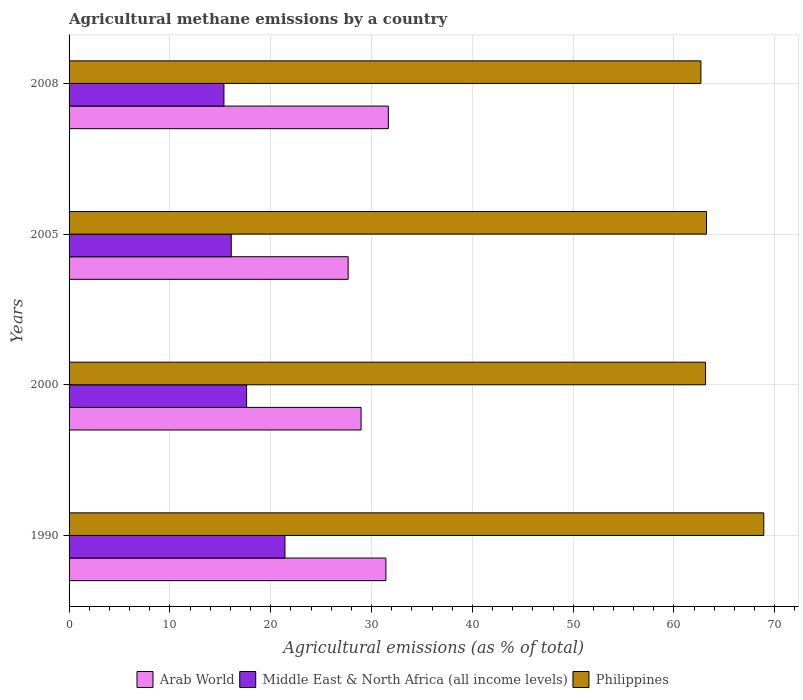Are the number of bars per tick equal to the number of legend labels?
Keep it short and to the point. Yes. Are the number of bars on each tick of the Y-axis equal?
Give a very brief answer. Yes. How many bars are there on the 3rd tick from the bottom?
Provide a succinct answer. 3. What is the amount of agricultural methane emitted in Philippines in 1990?
Keep it short and to the point. 68.9. Across all years, what is the maximum amount of agricultural methane emitted in Middle East & North Africa (all income levels)?
Provide a succinct answer. 21.41. Across all years, what is the minimum amount of agricultural methane emitted in Arab World?
Offer a terse response. 27.68. What is the total amount of agricultural methane emitted in Middle East & North Africa (all income levels) in the graph?
Offer a terse response. 70.47. What is the difference between the amount of agricultural methane emitted in Middle East & North Africa (all income levels) in 2000 and that in 2008?
Your response must be concise. 2.25. What is the difference between the amount of agricultural methane emitted in Arab World in 2005 and the amount of agricultural methane emitted in Middle East & North Africa (all income levels) in 2008?
Make the answer very short. 12.32. What is the average amount of agricultural methane emitted in Middle East & North Africa (all income levels) per year?
Make the answer very short. 17.62. In the year 1990, what is the difference between the amount of agricultural methane emitted in Middle East & North Africa (all income levels) and amount of agricultural methane emitted in Philippines?
Offer a terse response. -47.49. In how many years, is the amount of agricultural methane emitted in Arab World greater than 52 %?
Offer a very short reply. 0. What is the ratio of the amount of agricultural methane emitted in Philippines in 2000 to that in 2005?
Give a very brief answer. 1. Is the amount of agricultural methane emitted in Philippines in 1990 less than that in 2000?
Offer a very short reply. No. Is the difference between the amount of agricultural methane emitted in Middle East & North Africa (all income levels) in 1990 and 2000 greater than the difference between the amount of agricultural methane emitted in Philippines in 1990 and 2000?
Provide a succinct answer. No. What is the difference between the highest and the second highest amount of agricultural methane emitted in Arab World?
Ensure brevity in your answer.  0.24. What is the difference between the highest and the lowest amount of agricultural methane emitted in Middle East & North Africa (all income levels)?
Keep it short and to the point. 6.05. In how many years, is the amount of agricultural methane emitted in Arab World greater than the average amount of agricultural methane emitted in Arab World taken over all years?
Your answer should be compact. 2. What does the 1st bar from the top in 2000 represents?
Your answer should be very brief. Philippines. What does the 2nd bar from the bottom in 2005 represents?
Give a very brief answer. Middle East & North Africa (all income levels). Is it the case that in every year, the sum of the amount of agricultural methane emitted in Philippines and amount of agricultural methane emitted in Arab World is greater than the amount of agricultural methane emitted in Middle East & North Africa (all income levels)?
Provide a short and direct response. Yes. Are all the bars in the graph horizontal?
Your answer should be compact. Yes. What is the difference between two consecutive major ticks on the X-axis?
Offer a terse response. 10. Are the values on the major ticks of X-axis written in scientific E-notation?
Keep it short and to the point. No. Does the graph contain grids?
Provide a short and direct response. Yes. What is the title of the graph?
Your response must be concise. Agricultural methane emissions by a country. Does "Guyana" appear as one of the legend labels in the graph?
Offer a terse response. No. What is the label or title of the X-axis?
Provide a succinct answer. Agricultural emissions (as % of total). What is the Agricultural emissions (as % of total) in Arab World in 1990?
Keep it short and to the point. 31.42. What is the Agricultural emissions (as % of total) of Middle East & North Africa (all income levels) in 1990?
Offer a very short reply. 21.41. What is the Agricultural emissions (as % of total) in Philippines in 1990?
Your answer should be very brief. 68.9. What is the Agricultural emissions (as % of total) in Arab World in 2000?
Your response must be concise. 28.96. What is the Agricultural emissions (as % of total) in Middle East & North Africa (all income levels) in 2000?
Offer a very short reply. 17.61. What is the Agricultural emissions (as % of total) of Philippines in 2000?
Your response must be concise. 63.13. What is the Agricultural emissions (as % of total) of Arab World in 2005?
Your answer should be compact. 27.68. What is the Agricultural emissions (as % of total) of Middle East & North Africa (all income levels) in 2005?
Offer a terse response. 16.09. What is the Agricultural emissions (as % of total) in Philippines in 2005?
Ensure brevity in your answer.  63.22. What is the Agricultural emissions (as % of total) of Arab World in 2008?
Your answer should be very brief. 31.67. What is the Agricultural emissions (as % of total) in Middle East & North Africa (all income levels) in 2008?
Keep it short and to the point. 15.36. What is the Agricultural emissions (as % of total) of Philippines in 2008?
Your answer should be very brief. 62.67. Across all years, what is the maximum Agricultural emissions (as % of total) of Arab World?
Keep it short and to the point. 31.67. Across all years, what is the maximum Agricultural emissions (as % of total) of Middle East & North Africa (all income levels)?
Your response must be concise. 21.41. Across all years, what is the maximum Agricultural emissions (as % of total) in Philippines?
Offer a very short reply. 68.9. Across all years, what is the minimum Agricultural emissions (as % of total) in Arab World?
Keep it short and to the point. 27.68. Across all years, what is the minimum Agricultural emissions (as % of total) of Middle East & North Africa (all income levels)?
Offer a terse response. 15.36. Across all years, what is the minimum Agricultural emissions (as % of total) of Philippines?
Give a very brief answer. 62.67. What is the total Agricultural emissions (as % of total) of Arab World in the graph?
Provide a succinct answer. 119.73. What is the total Agricultural emissions (as % of total) of Middle East & North Africa (all income levels) in the graph?
Your response must be concise. 70.47. What is the total Agricultural emissions (as % of total) in Philippines in the graph?
Provide a succinct answer. 257.93. What is the difference between the Agricultural emissions (as % of total) of Arab World in 1990 and that in 2000?
Give a very brief answer. 2.46. What is the difference between the Agricultural emissions (as % of total) of Middle East & North Africa (all income levels) in 1990 and that in 2000?
Offer a terse response. 3.81. What is the difference between the Agricultural emissions (as % of total) of Philippines in 1990 and that in 2000?
Provide a succinct answer. 5.77. What is the difference between the Agricultural emissions (as % of total) of Arab World in 1990 and that in 2005?
Your response must be concise. 3.74. What is the difference between the Agricultural emissions (as % of total) in Middle East & North Africa (all income levels) in 1990 and that in 2005?
Offer a very short reply. 5.33. What is the difference between the Agricultural emissions (as % of total) of Philippines in 1990 and that in 2005?
Provide a succinct answer. 5.68. What is the difference between the Agricultural emissions (as % of total) of Arab World in 1990 and that in 2008?
Your answer should be very brief. -0.24. What is the difference between the Agricultural emissions (as % of total) in Middle East & North Africa (all income levels) in 1990 and that in 2008?
Offer a terse response. 6.05. What is the difference between the Agricultural emissions (as % of total) of Philippines in 1990 and that in 2008?
Your answer should be very brief. 6.23. What is the difference between the Agricultural emissions (as % of total) of Arab World in 2000 and that in 2005?
Your answer should be compact. 1.28. What is the difference between the Agricultural emissions (as % of total) in Middle East & North Africa (all income levels) in 2000 and that in 2005?
Your response must be concise. 1.52. What is the difference between the Agricultural emissions (as % of total) of Philippines in 2000 and that in 2005?
Offer a terse response. -0.09. What is the difference between the Agricultural emissions (as % of total) in Arab World in 2000 and that in 2008?
Provide a short and direct response. -2.7. What is the difference between the Agricultural emissions (as % of total) in Middle East & North Africa (all income levels) in 2000 and that in 2008?
Make the answer very short. 2.25. What is the difference between the Agricultural emissions (as % of total) in Philippines in 2000 and that in 2008?
Your answer should be compact. 0.46. What is the difference between the Agricultural emissions (as % of total) of Arab World in 2005 and that in 2008?
Your response must be concise. -3.99. What is the difference between the Agricultural emissions (as % of total) in Middle East & North Africa (all income levels) in 2005 and that in 2008?
Provide a short and direct response. 0.72. What is the difference between the Agricultural emissions (as % of total) in Philippines in 2005 and that in 2008?
Offer a terse response. 0.55. What is the difference between the Agricultural emissions (as % of total) in Arab World in 1990 and the Agricultural emissions (as % of total) in Middle East & North Africa (all income levels) in 2000?
Offer a very short reply. 13.81. What is the difference between the Agricultural emissions (as % of total) of Arab World in 1990 and the Agricultural emissions (as % of total) of Philippines in 2000?
Ensure brevity in your answer.  -31.71. What is the difference between the Agricultural emissions (as % of total) of Middle East & North Africa (all income levels) in 1990 and the Agricultural emissions (as % of total) of Philippines in 2000?
Give a very brief answer. -41.72. What is the difference between the Agricultural emissions (as % of total) of Arab World in 1990 and the Agricultural emissions (as % of total) of Middle East & North Africa (all income levels) in 2005?
Ensure brevity in your answer.  15.34. What is the difference between the Agricultural emissions (as % of total) in Arab World in 1990 and the Agricultural emissions (as % of total) in Philippines in 2005?
Offer a terse response. -31.8. What is the difference between the Agricultural emissions (as % of total) of Middle East & North Africa (all income levels) in 1990 and the Agricultural emissions (as % of total) of Philippines in 2005?
Provide a succinct answer. -41.81. What is the difference between the Agricultural emissions (as % of total) of Arab World in 1990 and the Agricultural emissions (as % of total) of Middle East & North Africa (all income levels) in 2008?
Offer a terse response. 16.06. What is the difference between the Agricultural emissions (as % of total) in Arab World in 1990 and the Agricultural emissions (as % of total) in Philippines in 2008?
Offer a very short reply. -31.25. What is the difference between the Agricultural emissions (as % of total) of Middle East & North Africa (all income levels) in 1990 and the Agricultural emissions (as % of total) of Philippines in 2008?
Provide a succinct answer. -41.26. What is the difference between the Agricultural emissions (as % of total) of Arab World in 2000 and the Agricultural emissions (as % of total) of Middle East & North Africa (all income levels) in 2005?
Make the answer very short. 12.88. What is the difference between the Agricultural emissions (as % of total) in Arab World in 2000 and the Agricultural emissions (as % of total) in Philippines in 2005?
Your response must be concise. -34.26. What is the difference between the Agricultural emissions (as % of total) of Middle East & North Africa (all income levels) in 2000 and the Agricultural emissions (as % of total) of Philippines in 2005?
Provide a succinct answer. -45.62. What is the difference between the Agricultural emissions (as % of total) in Arab World in 2000 and the Agricultural emissions (as % of total) in Middle East & North Africa (all income levels) in 2008?
Provide a short and direct response. 13.6. What is the difference between the Agricultural emissions (as % of total) in Arab World in 2000 and the Agricultural emissions (as % of total) in Philippines in 2008?
Provide a short and direct response. -33.71. What is the difference between the Agricultural emissions (as % of total) in Middle East & North Africa (all income levels) in 2000 and the Agricultural emissions (as % of total) in Philippines in 2008?
Your answer should be compact. -45.06. What is the difference between the Agricultural emissions (as % of total) in Arab World in 2005 and the Agricultural emissions (as % of total) in Middle East & North Africa (all income levels) in 2008?
Make the answer very short. 12.32. What is the difference between the Agricultural emissions (as % of total) in Arab World in 2005 and the Agricultural emissions (as % of total) in Philippines in 2008?
Make the answer very short. -34.99. What is the difference between the Agricultural emissions (as % of total) in Middle East & North Africa (all income levels) in 2005 and the Agricultural emissions (as % of total) in Philippines in 2008?
Make the answer very short. -46.59. What is the average Agricultural emissions (as % of total) of Arab World per year?
Offer a very short reply. 29.93. What is the average Agricultural emissions (as % of total) of Middle East & North Africa (all income levels) per year?
Your answer should be compact. 17.62. What is the average Agricultural emissions (as % of total) in Philippines per year?
Your answer should be compact. 64.48. In the year 1990, what is the difference between the Agricultural emissions (as % of total) in Arab World and Agricultural emissions (as % of total) in Middle East & North Africa (all income levels)?
Ensure brevity in your answer.  10.01. In the year 1990, what is the difference between the Agricultural emissions (as % of total) in Arab World and Agricultural emissions (as % of total) in Philippines?
Ensure brevity in your answer.  -37.48. In the year 1990, what is the difference between the Agricultural emissions (as % of total) in Middle East & North Africa (all income levels) and Agricultural emissions (as % of total) in Philippines?
Your response must be concise. -47.49. In the year 2000, what is the difference between the Agricultural emissions (as % of total) of Arab World and Agricultural emissions (as % of total) of Middle East & North Africa (all income levels)?
Provide a short and direct response. 11.35. In the year 2000, what is the difference between the Agricultural emissions (as % of total) of Arab World and Agricultural emissions (as % of total) of Philippines?
Your answer should be very brief. -34.17. In the year 2000, what is the difference between the Agricultural emissions (as % of total) in Middle East & North Africa (all income levels) and Agricultural emissions (as % of total) in Philippines?
Provide a short and direct response. -45.52. In the year 2005, what is the difference between the Agricultural emissions (as % of total) of Arab World and Agricultural emissions (as % of total) of Middle East & North Africa (all income levels)?
Offer a very short reply. 11.59. In the year 2005, what is the difference between the Agricultural emissions (as % of total) of Arab World and Agricultural emissions (as % of total) of Philippines?
Ensure brevity in your answer.  -35.54. In the year 2005, what is the difference between the Agricultural emissions (as % of total) of Middle East & North Africa (all income levels) and Agricultural emissions (as % of total) of Philippines?
Your response must be concise. -47.14. In the year 2008, what is the difference between the Agricultural emissions (as % of total) in Arab World and Agricultural emissions (as % of total) in Middle East & North Africa (all income levels)?
Keep it short and to the point. 16.31. In the year 2008, what is the difference between the Agricultural emissions (as % of total) of Arab World and Agricultural emissions (as % of total) of Philippines?
Make the answer very short. -31. In the year 2008, what is the difference between the Agricultural emissions (as % of total) of Middle East & North Africa (all income levels) and Agricultural emissions (as % of total) of Philippines?
Your answer should be very brief. -47.31. What is the ratio of the Agricultural emissions (as % of total) in Arab World in 1990 to that in 2000?
Make the answer very short. 1.08. What is the ratio of the Agricultural emissions (as % of total) of Middle East & North Africa (all income levels) in 1990 to that in 2000?
Provide a succinct answer. 1.22. What is the ratio of the Agricultural emissions (as % of total) of Philippines in 1990 to that in 2000?
Provide a short and direct response. 1.09. What is the ratio of the Agricultural emissions (as % of total) in Arab World in 1990 to that in 2005?
Offer a very short reply. 1.14. What is the ratio of the Agricultural emissions (as % of total) in Middle East & North Africa (all income levels) in 1990 to that in 2005?
Your answer should be very brief. 1.33. What is the ratio of the Agricultural emissions (as % of total) in Philippines in 1990 to that in 2005?
Keep it short and to the point. 1.09. What is the ratio of the Agricultural emissions (as % of total) of Middle East & North Africa (all income levels) in 1990 to that in 2008?
Make the answer very short. 1.39. What is the ratio of the Agricultural emissions (as % of total) in Philippines in 1990 to that in 2008?
Your answer should be compact. 1.1. What is the ratio of the Agricultural emissions (as % of total) in Arab World in 2000 to that in 2005?
Keep it short and to the point. 1.05. What is the ratio of the Agricultural emissions (as % of total) of Middle East & North Africa (all income levels) in 2000 to that in 2005?
Provide a succinct answer. 1.09. What is the ratio of the Agricultural emissions (as % of total) of Arab World in 2000 to that in 2008?
Give a very brief answer. 0.91. What is the ratio of the Agricultural emissions (as % of total) in Middle East & North Africa (all income levels) in 2000 to that in 2008?
Your answer should be compact. 1.15. What is the ratio of the Agricultural emissions (as % of total) of Philippines in 2000 to that in 2008?
Offer a terse response. 1.01. What is the ratio of the Agricultural emissions (as % of total) in Arab World in 2005 to that in 2008?
Your answer should be compact. 0.87. What is the ratio of the Agricultural emissions (as % of total) of Middle East & North Africa (all income levels) in 2005 to that in 2008?
Offer a terse response. 1.05. What is the ratio of the Agricultural emissions (as % of total) of Philippines in 2005 to that in 2008?
Offer a terse response. 1.01. What is the difference between the highest and the second highest Agricultural emissions (as % of total) in Arab World?
Keep it short and to the point. 0.24. What is the difference between the highest and the second highest Agricultural emissions (as % of total) in Middle East & North Africa (all income levels)?
Offer a very short reply. 3.81. What is the difference between the highest and the second highest Agricultural emissions (as % of total) in Philippines?
Keep it short and to the point. 5.68. What is the difference between the highest and the lowest Agricultural emissions (as % of total) of Arab World?
Provide a short and direct response. 3.99. What is the difference between the highest and the lowest Agricultural emissions (as % of total) of Middle East & North Africa (all income levels)?
Give a very brief answer. 6.05. What is the difference between the highest and the lowest Agricultural emissions (as % of total) of Philippines?
Keep it short and to the point. 6.23. 